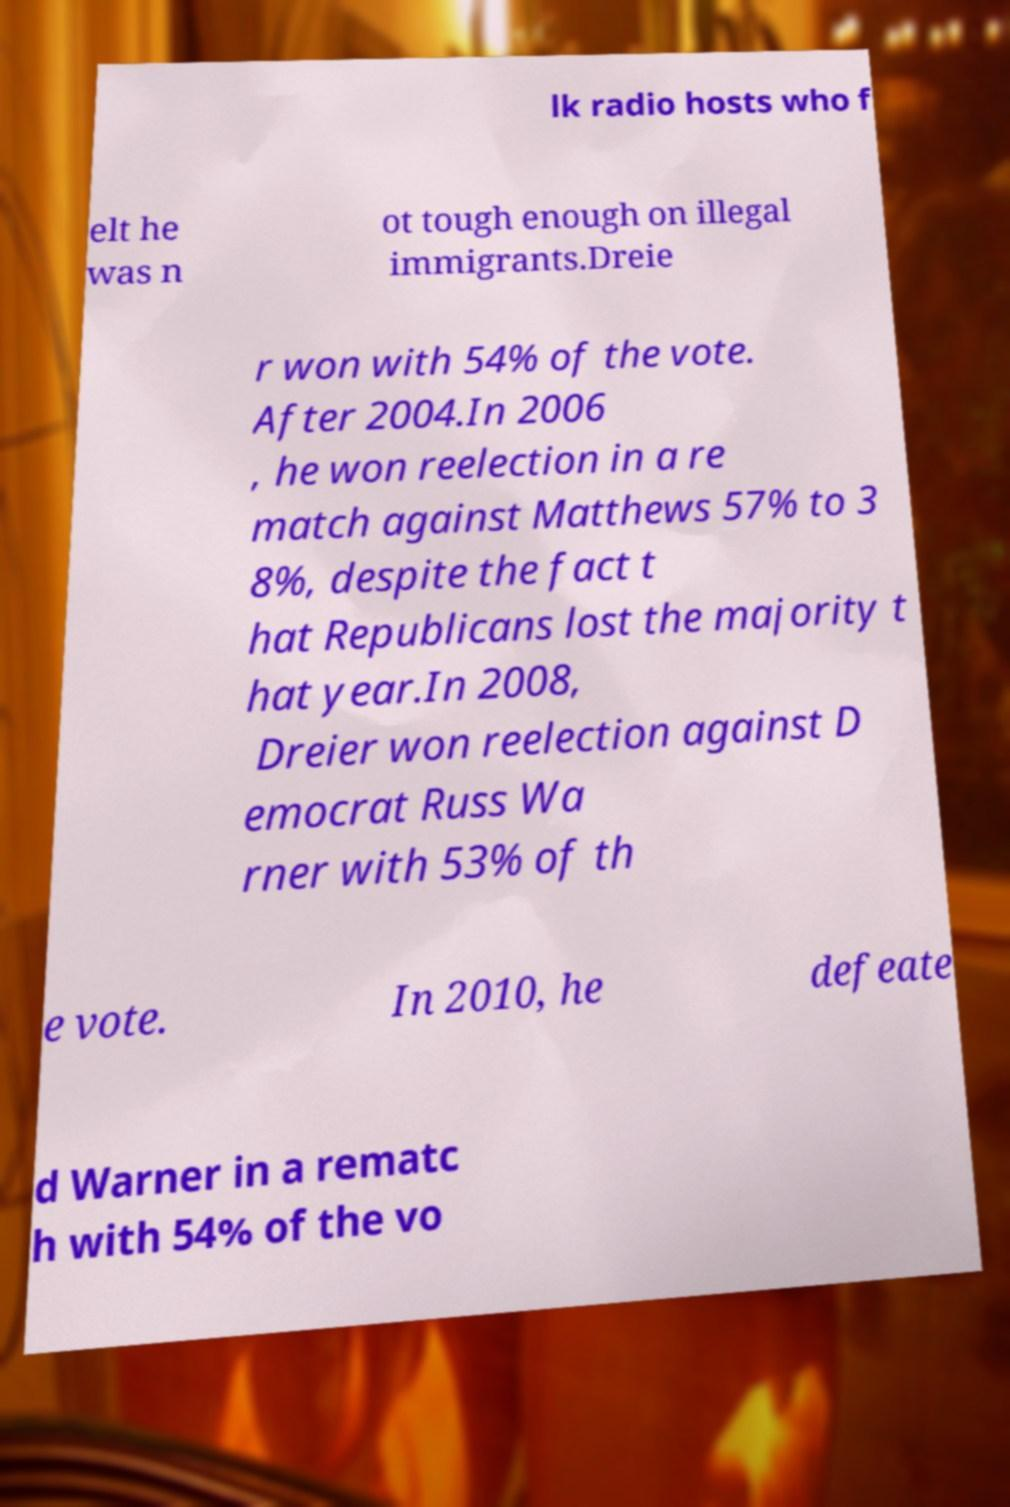There's text embedded in this image that I need extracted. Can you transcribe it verbatim? lk radio hosts who f elt he was n ot tough enough on illegal immigrants.Dreie r won with 54% of the vote. After 2004.In 2006 , he won reelection in a re match against Matthews 57% to 3 8%, despite the fact t hat Republicans lost the majority t hat year.In 2008, Dreier won reelection against D emocrat Russ Wa rner with 53% of th e vote. In 2010, he defeate d Warner in a rematc h with 54% of the vo 